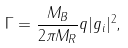Convert formula to latex. <formula><loc_0><loc_0><loc_500><loc_500>\Gamma = \frac { M _ { B } } { 2 \pi M _ { R } } q | g _ { i } | ^ { 2 } ,</formula> 